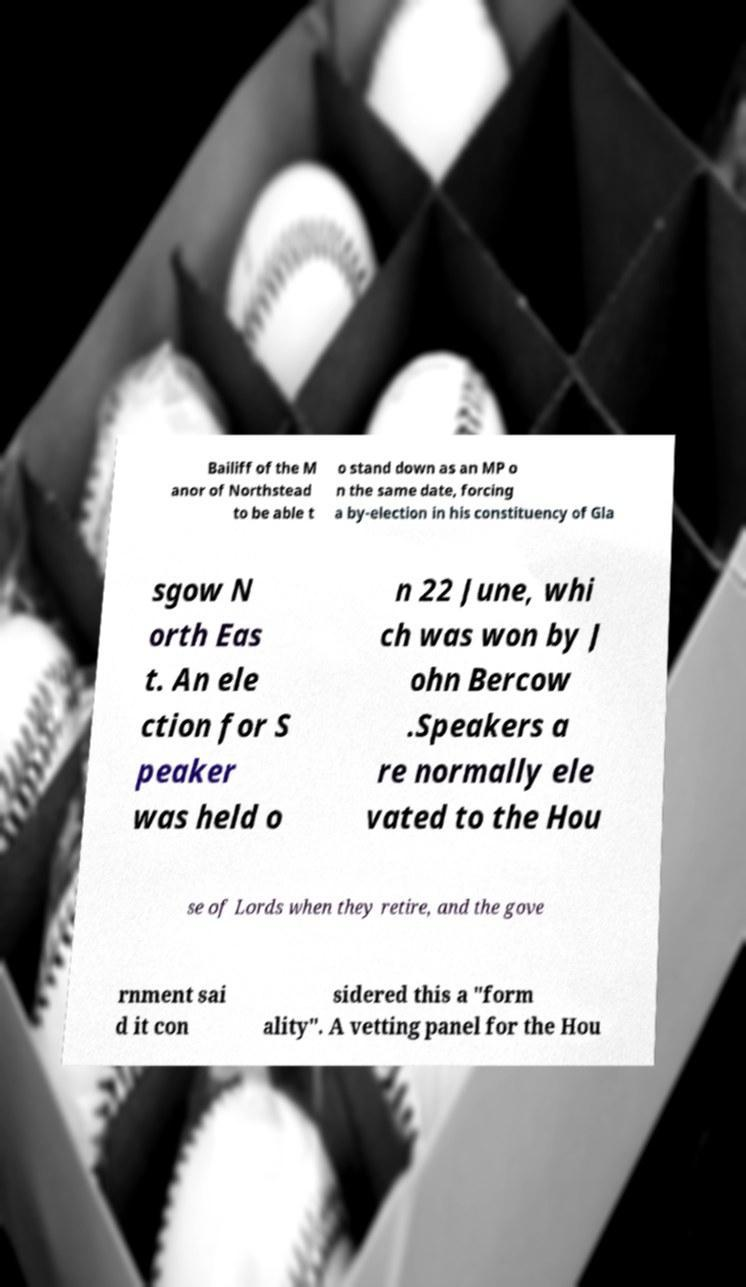Could you extract and type out the text from this image? Bailiff of the M anor of Northstead to be able t o stand down as an MP o n the same date, forcing a by-election in his constituency of Gla sgow N orth Eas t. An ele ction for S peaker was held o n 22 June, whi ch was won by J ohn Bercow .Speakers a re normally ele vated to the Hou se of Lords when they retire, and the gove rnment sai d it con sidered this a "form ality". A vetting panel for the Hou 